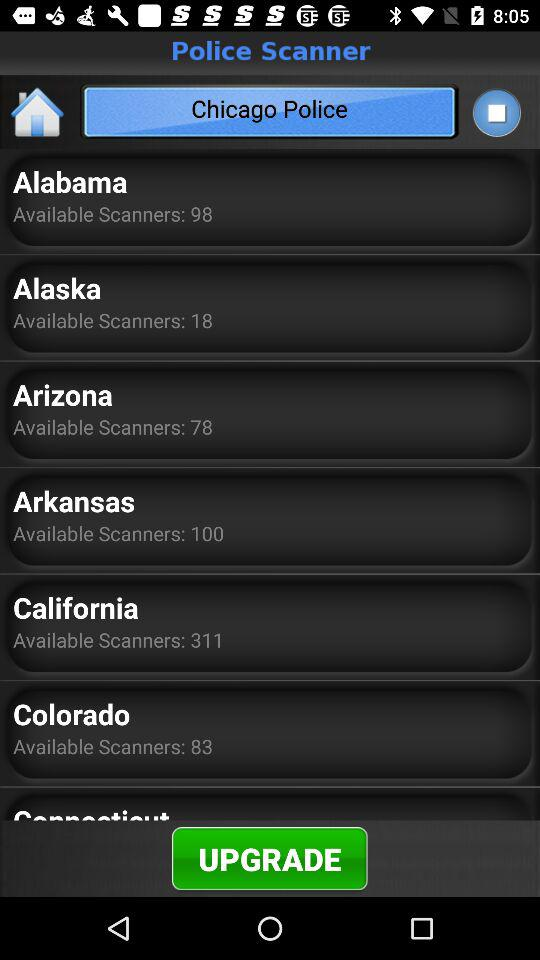How many scanners are available in Alaska? There are 18 scanners available in Alaska. 